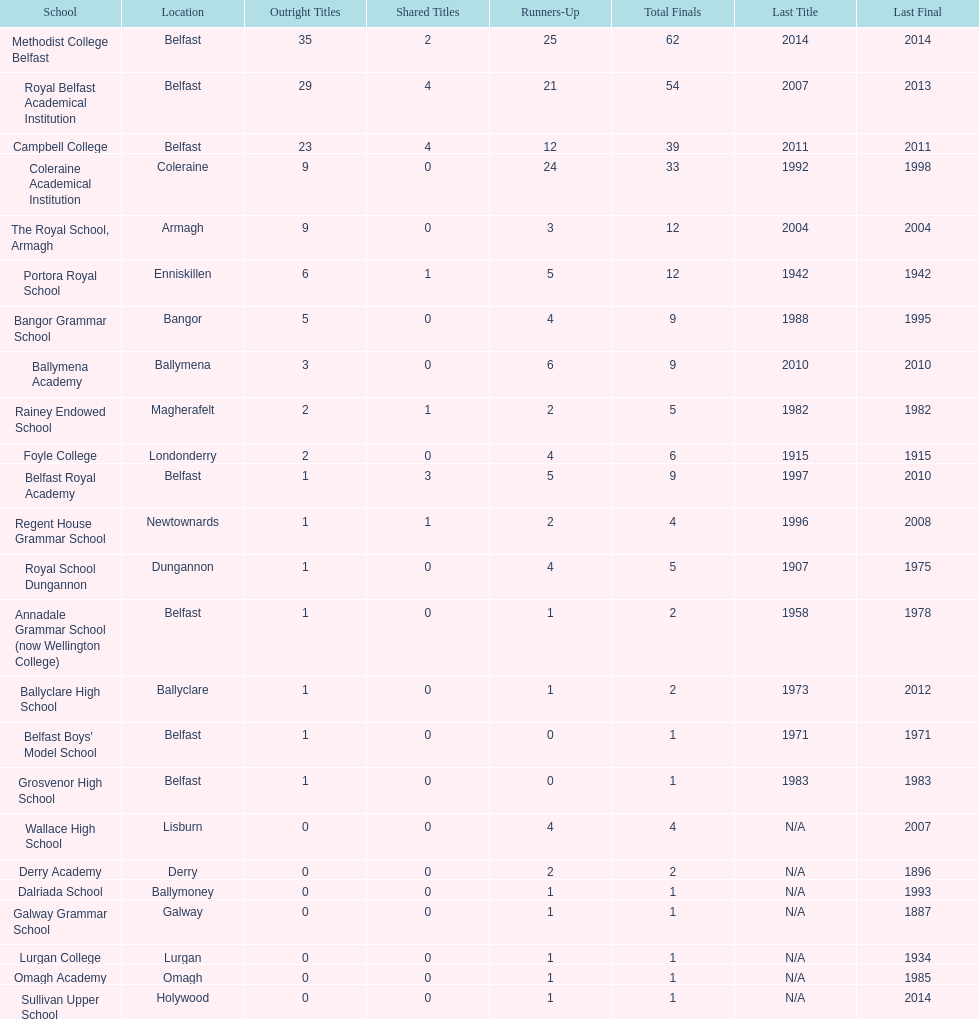Help me parse the entirety of this table. {'header': ['School', 'Location', 'Outright Titles', 'Shared Titles', 'Runners-Up', 'Total Finals', 'Last Title', 'Last Final'], 'rows': [['Methodist College Belfast', 'Belfast', '35', '2', '25', '62', '2014', '2014'], ['Royal Belfast Academical Institution', 'Belfast', '29', '4', '21', '54', '2007', '2013'], ['Campbell College', 'Belfast', '23', '4', '12', '39', '2011', '2011'], ['Coleraine Academical Institution', 'Coleraine', '9', '0', '24', '33', '1992', '1998'], ['The Royal School, Armagh', 'Armagh', '9', '0', '3', '12', '2004', '2004'], ['Portora Royal School', 'Enniskillen', '6', '1', '5', '12', '1942', '1942'], ['Bangor Grammar School', 'Bangor', '5', '0', '4', '9', '1988', '1995'], ['Ballymena Academy', 'Ballymena', '3', '0', '6', '9', '2010', '2010'], ['Rainey Endowed School', 'Magherafelt', '2', '1', '2', '5', '1982', '1982'], ['Foyle College', 'Londonderry', '2', '0', '4', '6', '1915', '1915'], ['Belfast Royal Academy', 'Belfast', '1', '3', '5', '9', '1997', '2010'], ['Regent House Grammar School', 'Newtownards', '1', '1', '2', '4', '1996', '2008'], ['Royal School Dungannon', 'Dungannon', '1', '0', '4', '5', '1907', '1975'], ['Annadale Grammar School (now Wellington College)', 'Belfast', '1', '0', '1', '2', '1958', '1978'], ['Ballyclare High School', 'Ballyclare', '1', '0', '1', '2', '1973', '2012'], ["Belfast Boys' Model School", 'Belfast', '1', '0', '0', '1', '1971', '1971'], ['Grosvenor High School', 'Belfast', '1', '0', '0', '1', '1983', '1983'], ['Wallace High School', 'Lisburn', '0', '0', '4', '4', 'N/A', '2007'], ['Derry Academy', 'Derry', '0', '0', '2', '2', 'N/A', '1896'], ['Dalriada School', 'Ballymoney', '0', '0', '1', '1', 'N/A', '1993'], ['Galway Grammar School', 'Galway', '0', '0', '1', '1', 'N/A', '1887'], ['Lurgan College', 'Lurgan', '0', '0', '1', '1', 'N/A', '1934'], ['Omagh Academy', 'Omagh', '0', '0', '1', '1', 'N/A', '1985'], ['Sullivan Upper School', 'Holywood', '0', '0', '1', '1', 'N/A', '2014']]} How many schools had above 5 outright titles? 6. 